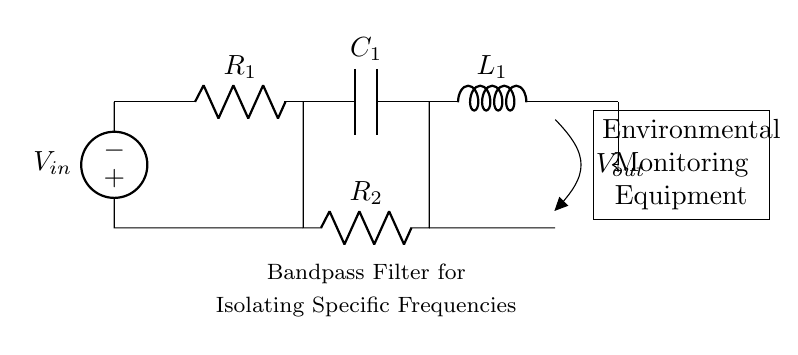What is the input voltage source? The input voltage source is labeled as V_in in the circuit diagram, indicating the point where the input voltage is applied.
Answer: V_in What are the components used in this filter? The components shown in the diagram include resistors, a capacitor, and an inductor, specifically R_1, C_1, L_1, and R_2.
Answer: R_1, C_1, L_1, R_2 What is the function of the capacitor in this circuit? The capacitor, C_1, in a bandpass filter is used to allow specific frequencies to pass while blocking others, contributing to the filter's ability to isolate a specific frequency range.
Answer: Isolating frequencies How many resistors are present in the circuit? The circuit contains two resistors, R_1 and R_2, positioned at different parts of the circuit.
Answer: Two What is the purpose of the bandpass filter in this diagram? The bandpass filter is designed to isolate and allow a specific frequency range of signals to pass through while attenuating frequencies outside this range, as indicated in the label below the circuit.
Answer: Isolating specific frequencies What is the output voltage node labeled as? The output of the circuit is labeled as V_out, indicating where the filtered signal can be extracted from the circuit.
Answer: V_out 